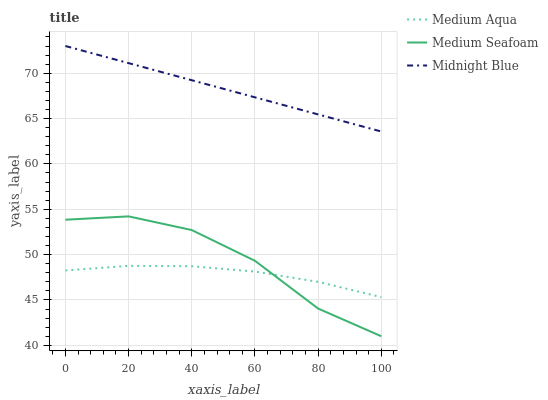Does Medium Aqua have the minimum area under the curve?
Answer yes or no. Yes. Does Midnight Blue have the maximum area under the curve?
Answer yes or no. Yes. Does Medium Seafoam have the minimum area under the curve?
Answer yes or no. No. Does Medium Seafoam have the maximum area under the curve?
Answer yes or no. No. Is Midnight Blue the smoothest?
Answer yes or no. Yes. Is Medium Seafoam the roughest?
Answer yes or no. Yes. Is Medium Seafoam the smoothest?
Answer yes or no. No. Is Midnight Blue the roughest?
Answer yes or no. No. Does Medium Seafoam have the lowest value?
Answer yes or no. Yes. Does Midnight Blue have the lowest value?
Answer yes or no. No. Does Midnight Blue have the highest value?
Answer yes or no. Yes. Does Medium Seafoam have the highest value?
Answer yes or no. No. Is Medium Aqua less than Midnight Blue?
Answer yes or no. Yes. Is Midnight Blue greater than Medium Seafoam?
Answer yes or no. Yes. Does Medium Seafoam intersect Medium Aqua?
Answer yes or no. Yes. Is Medium Seafoam less than Medium Aqua?
Answer yes or no. No. Is Medium Seafoam greater than Medium Aqua?
Answer yes or no. No. Does Medium Aqua intersect Midnight Blue?
Answer yes or no. No. 